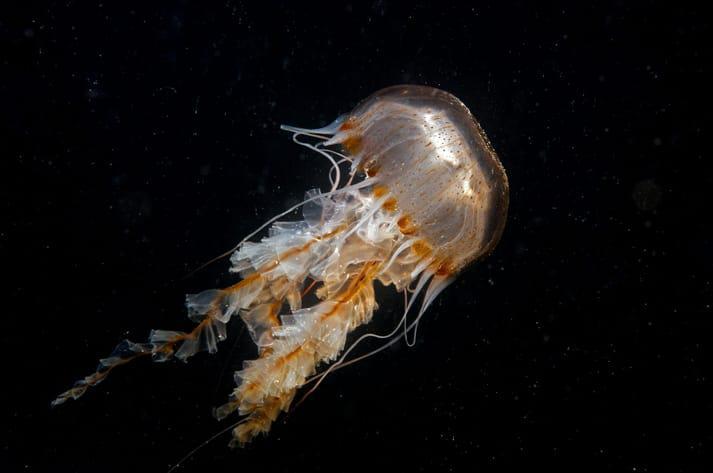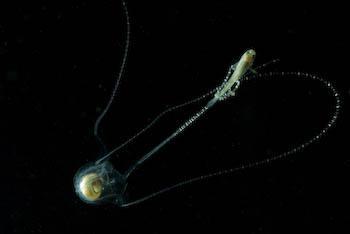The first image is the image on the left, the second image is the image on the right. Given the left and right images, does the statement "Two clear jellyfish are swimming downwards." hold true? Answer yes or no. No. The first image is the image on the left, the second image is the image on the right. Evaluate the accuracy of this statement regarding the images: "Both jellyfish are upside down.". Is it true? Answer yes or no. No. 